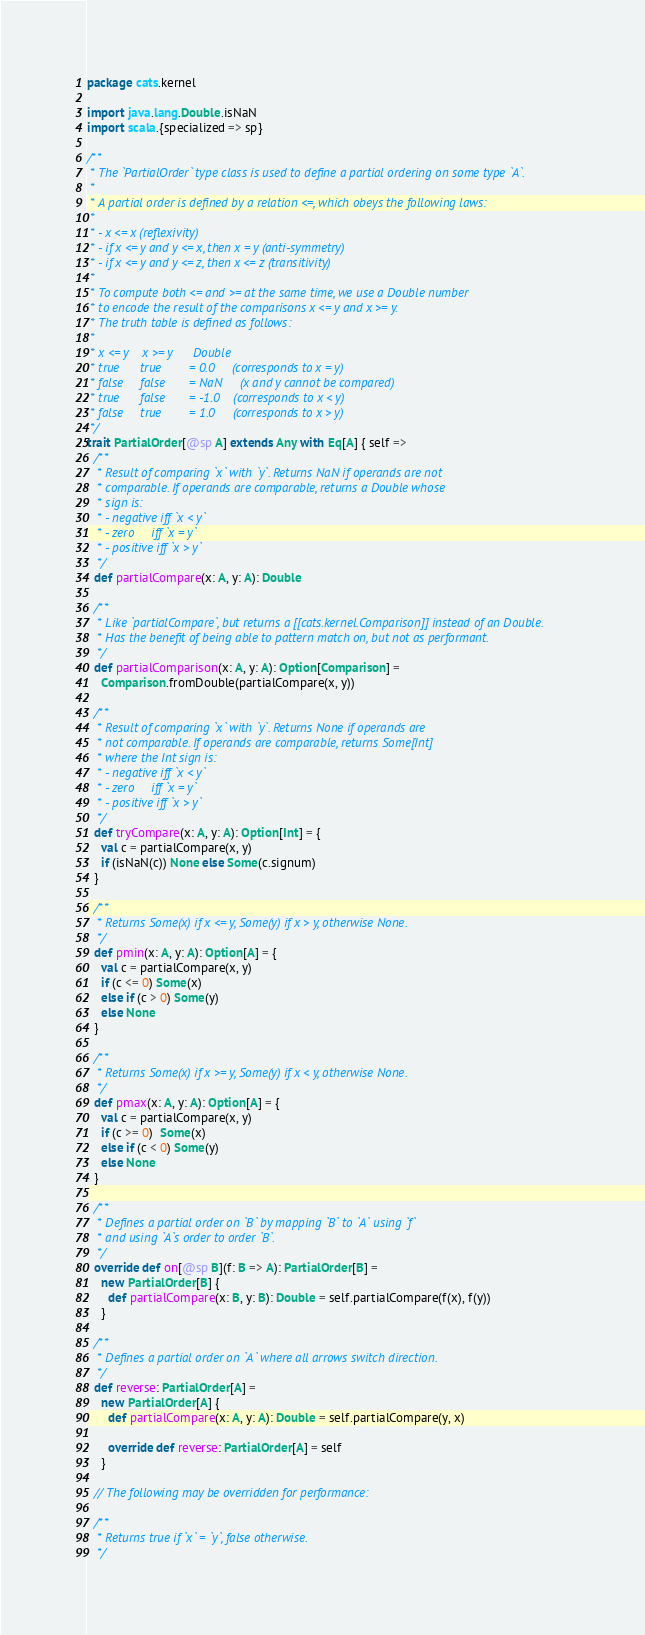Convert code to text. <code><loc_0><loc_0><loc_500><loc_500><_Scala_>package cats.kernel

import java.lang.Double.isNaN
import scala.{specialized => sp}

/**
 * The `PartialOrder` type class is used to define a partial ordering on some type `A`.
 *
 * A partial order is defined by a relation <=, which obeys the following laws:
 *
 * - x <= x (reflexivity)
 * - if x <= y and y <= x, then x = y (anti-symmetry)
 * - if x <= y and y <= z, then x <= z (transitivity)
 *
 * To compute both <= and >= at the same time, we use a Double number
 * to encode the result of the comparisons x <= y and x >= y.
 * The truth table is defined as follows:
 *
 * x <= y    x >= y      Double
 * true      true        = 0.0     (corresponds to x = y)
 * false     false       = NaN     (x and y cannot be compared)
 * true      false       = -1.0    (corresponds to x < y)
 * false     true        = 1.0     (corresponds to x > y)
 */
trait PartialOrder[@sp A] extends Any with Eq[A] { self =>
  /**
   * Result of comparing `x` with `y`. Returns NaN if operands are not
   * comparable. If operands are comparable, returns a Double whose
   * sign is:
   * - negative iff `x < y`
   * - zero     iff `x = y`
   * - positive iff `x > y`
   */
  def partialCompare(x: A, y: A): Double

  /**
   * Like `partialCompare`, but returns a [[cats.kernel.Comparison]] instead of an Double.
   * Has the benefit of being able to pattern match on, but not as performant.
   */
  def partialComparison(x: A, y: A): Option[Comparison] =
    Comparison.fromDouble(partialCompare(x, y))

  /**
   * Result of comparing `x` with `y`. Returns None if operands are
   * not comparable. If operands are comparable, returns Some[Int]
   * where the Int sign is:
   * - negative iff `x < y`
   * - zero     iff `x = y`
   * - positive iff `x > y`
   */
  def tryCompare(x: A, y: A): Option[Int] = {
    val c = partialCompare(x, y)
    if (isNaN(c)) None else Some(c.signum)
  }

  /**
   * Returns Some(x) if x <= y, Some(y) if x > y, otherwise None.
   */
  def pmin(x: A, y: A): Option[A] = {
    val c = partialCompare(x, y)
    if (c <= 0) Some(x)
    else if (c > 0) Some(y)
    else None
  }

  /**
   * Returns Some(x) if x >= y, Some(y) if x < y, otherwise None.
   */
  def pmax(x: A, y: A): Option[A] = {
    val c = partialCompare(x, y)
    if (c >= 0)  Some(x)
    else if (c < 0) Some(y)
    else None
  }

  /**
   * Defines a partial order on `B` by mapping `B` to `A` using `f`
   * and using `A`s order to order `B`.
   */
  override def on[@sp B](f: B => A): PartialOrder[B] =
    new PartialOrder[B] {
      def partialCompare(x: B, y: B): Double = self.partialCompare(f(x), f(y))
    }

  /**
   * Defines a partial order on `A` where all arrows switch direction.
   */
  def reverse: PartialOrder[A] =
    new PartialOrder[A] {
      def partialCompare(x: A, y: A): Double = self.partialCompare(y, x)

      override def reverse: PartialOrder[A] = self
    }

  // The following may be overridden for performance:

  /**
   * Returns true if `x` = `y`, false otherwise.
   */</code> 